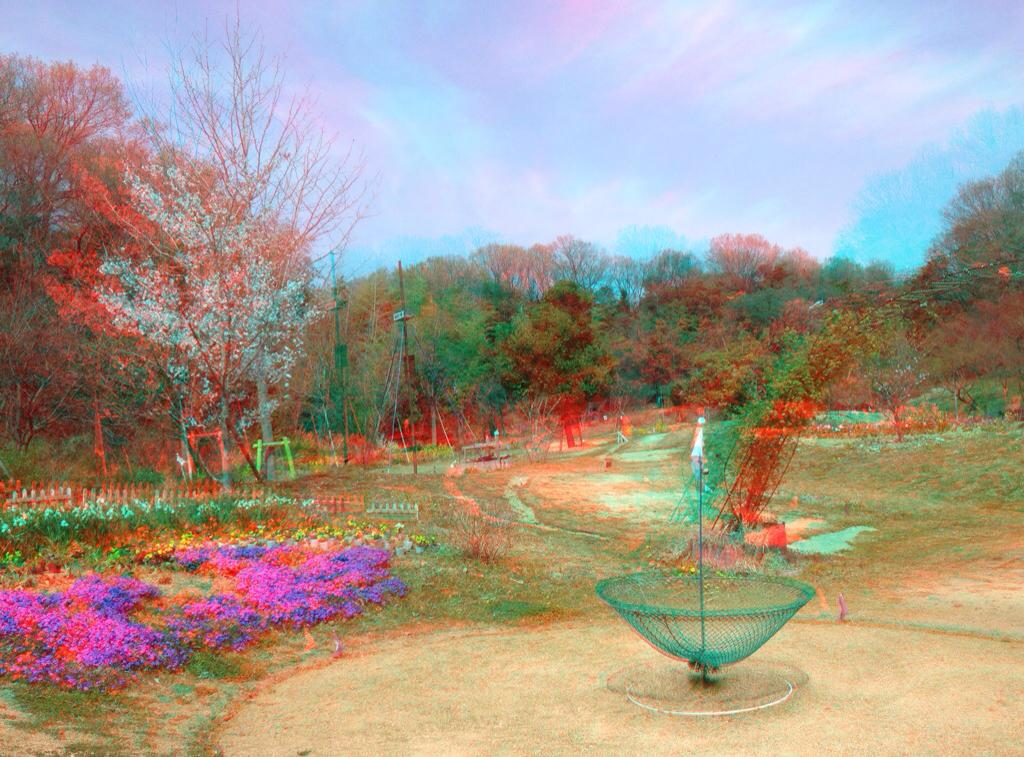What type of vegetation can be seen in the image? There are trees, plants, and flowers in the image. What structures are present in the image? There are poles and stands in the image. What additional feature can be seen in the image? There is a net in the image. What parts of the environment are visible in the image? The sky is visible at the top of the image, and the ground is visible at the bottom of the image. Where is the hall located in the image? There is no mention of a hall in the image; it only describes trees, poles, stands, plants, flowers, a net, the sky, and the ground. What is the cause of the argument in the image? There is no mention of an argument in the image; it only describes trees, poles, stands, plants, flowers, a net, the sky, and the ground. 